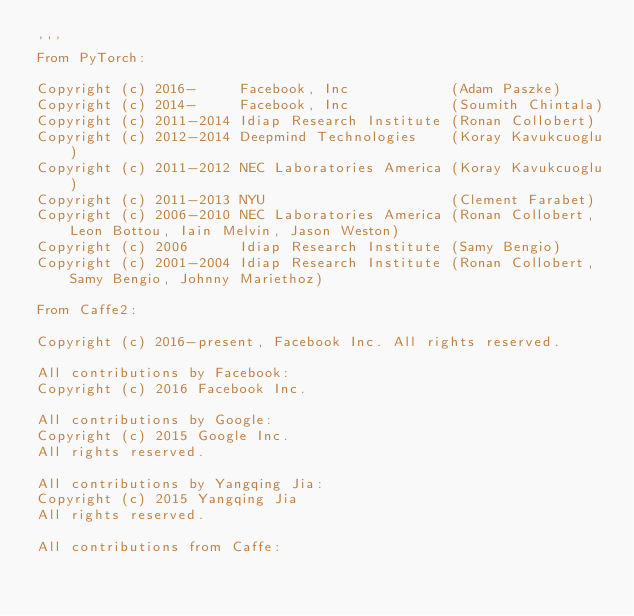Convert code to text. <code><loc_0><loc_0><loc_500><loc_500><_Python_>'''
From PyTorch:

Copyright (c) 2016-     Facebook, Inc            (Adam Paszke)
Copyright (c) 2014-     Facebook, Inc            (Soumith Chintala)
Copyright (c) 2011-2014 Idiap Research Institute (Ronan Collobert)
Copyright (c) 2012-2014 Deepmind Technologies    (Koray Kavukcuoglu)
Copyright (c) 2011-2012 NEC Laboratories America (Koray Kavukcuoglu)
Copyright (c) 2011-2013 NYU                      (Clement Farabet)
Copyright (c) 2006-2010 NEC Laboratories America (Ronan Collobert, Leon Bottou, Iain Melvin, Jason Weston)
Copyright (c) 2006      Idiap Research Institute (Samy Bengio)
Copyright (c) 2001-2004 Idiap Research Institute (Ronan Collobert, Samy Bengio, Johnny Mariethoz)

From Caffe2:

Copyright (c) 2016-present, Facebook Inc. All rights reserved.

All contributions by Facebook:
Copyright (c) 2016 Facebook Inc.
 
All contributions by Google:
Copyright (c) 2015 Google Inc.
All rights reserved.
 
All contributions by Yangqing Jia:
Copyright (c) 2015 Yangqing Jia
All rights reserved.
 
All contributions from Caffe:</code> 